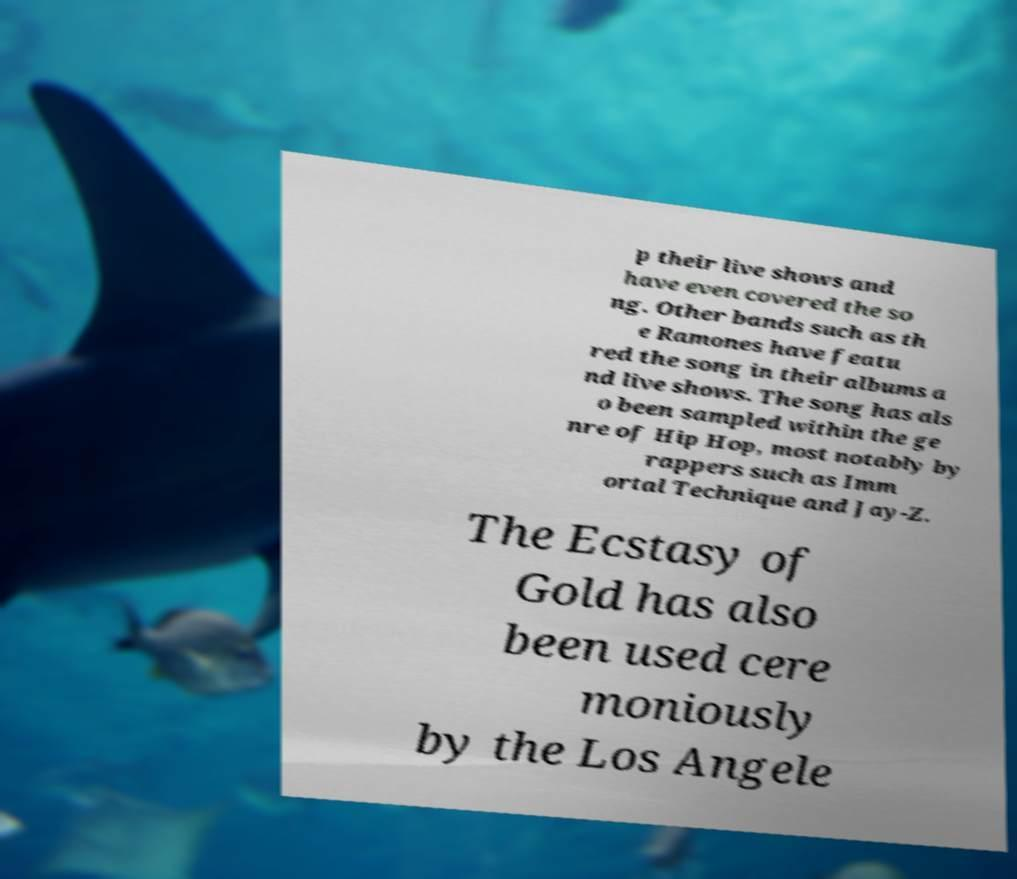I need the written content from this picture converted into text. Can you do that? p their live shows and have even covered the so ng. Other bands such as th e Ramones have featu red the song in their albums a nd live shows. The song has als o been sampled within the ge nre of Hip Hop, most notably by rappers such as Imm ortal Technique and Jay-Z. The Ecstasy of Gold has also been used cere moniously by the Los Angele 